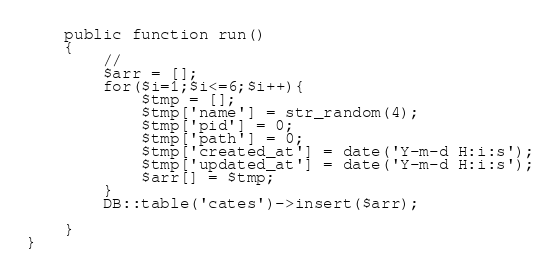<code> <loc_0><loc_0><loc_500><loc_500><_PHP_>    public function run()
    {
        //
        $arr = [];
        for($i=1;$i<=6;$i++){
        	$tmp = [];
        	$tmp['name'] = str_random(4);
        	$tmp['pid'] = 0;
        	$tmp['path'] = 0;
        	$tmp['created_at'] = date('Y-m-d H:i:s');
        	$tmp['updated_at'] = date('Y-m-d H:i:s');
        	$arr[] = $tmp;
        }
        DB::table('cates')->insert($arr);

    }
}
</code> 